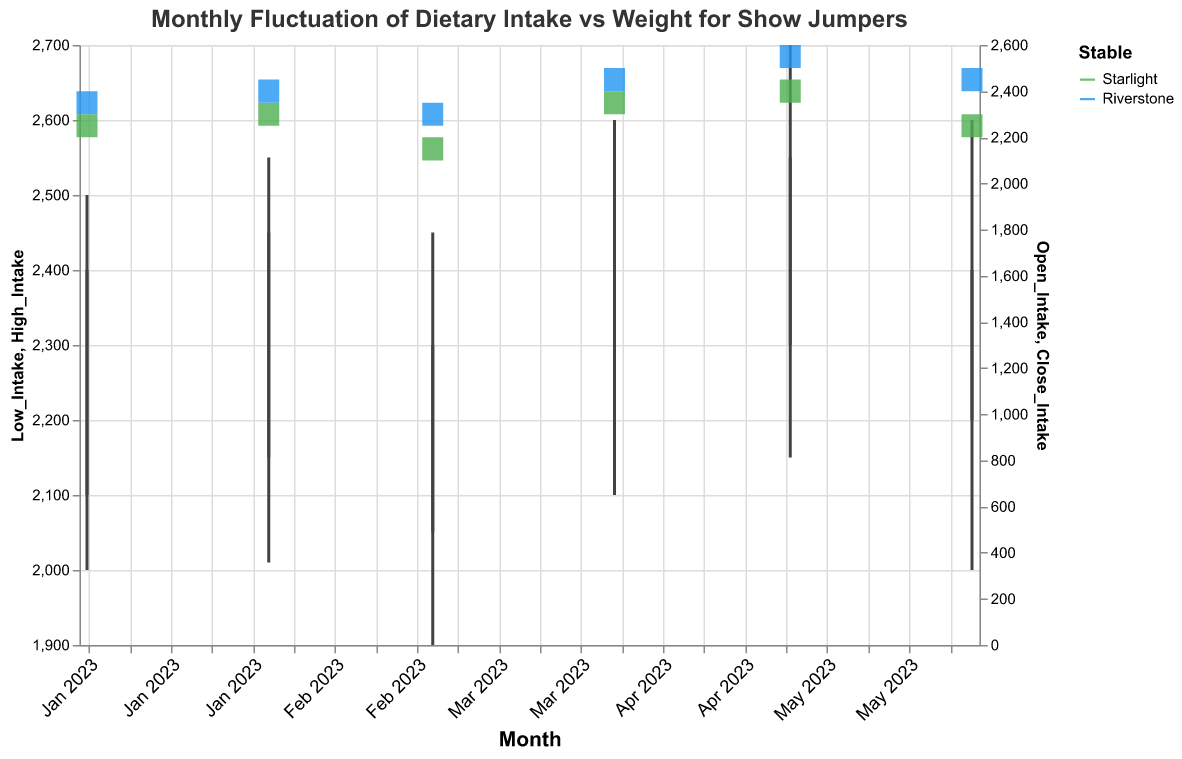What's the title of the figure? The title is positioned at the top of the figure and provides an overview of what the figure represents.
Answer: Monthly Fluctuation of Dietary Intake vs Weight for Show Jumpers What is the color used to represent the stable "Starlight"? The figure uses different colors to represent different stables. By looking at the color legend, we can see that "Starlight" is represented by green.
Answer: Green What months are shown in the figure? The x-axis of the figure shows the time frame covered by the data, with labels for each month.
Answer: January 2023 to June 2023 Which stable had the highest dietary intake in June 2023? By looking at June 2023 data points and comparing the high intake values of both Starlight and Riverstone, we can see which one is higher.
Answer: Riverstone How did the weight of show jumpers in the Starlight stable change from January 2023 to June 2023? By looking at the weight values for the Starlight stable from January to June, we can note the increase or decrease in weight.
Answer: It fluctuated but remained generally the same, around 700 What's the difference between the high dietary intake of Starlight in April 2023 and March 2023? We find the high dietary intake values for both months and calculate the difference by subtracting March's value from April's value.
Answer: 200 (2500 - 2300) Which stable had a greater increase in weight from March to April 2023? By comparing the closing weight values for each stable in March and April, we can see which one had a larger increase.
Answer: Starlight Did the dietary intake for Riverstone increase or decrease from May to June 2023? We compare the close intake values of Riverstone in May and June to see if there was an increase or decrease.
Answer: Decrease In which month did the Starlight stable show the most fluctuation in dietary intake? By observing the candlestick bars for Starlight, the most extended bar indicates the most fluctuation.
Answer: March 2023 What's the open weight for Riverstone stable in February 2023? By hovering over or finding the tooltip for the respective month and stable, we can identify the open weight value.
Answer: 705 